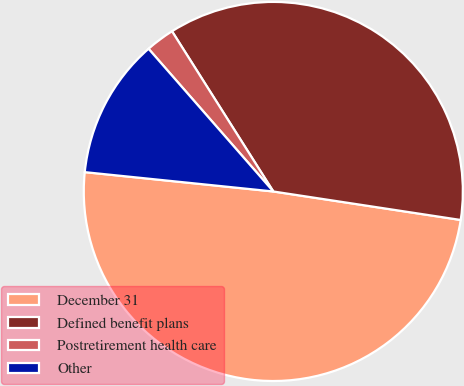Convert chart to OTSL. <chart><loc_0><loc_0><loc_500><loc_500><pie_chart><fcel>December 31<fcel>Defined benefit plans<fcel>Postretirement health care<fcel>Other<nl><fcel>49.23%<fcel>36.38%<fcel>2.46%<fcel>11.94%<nl></chart> 